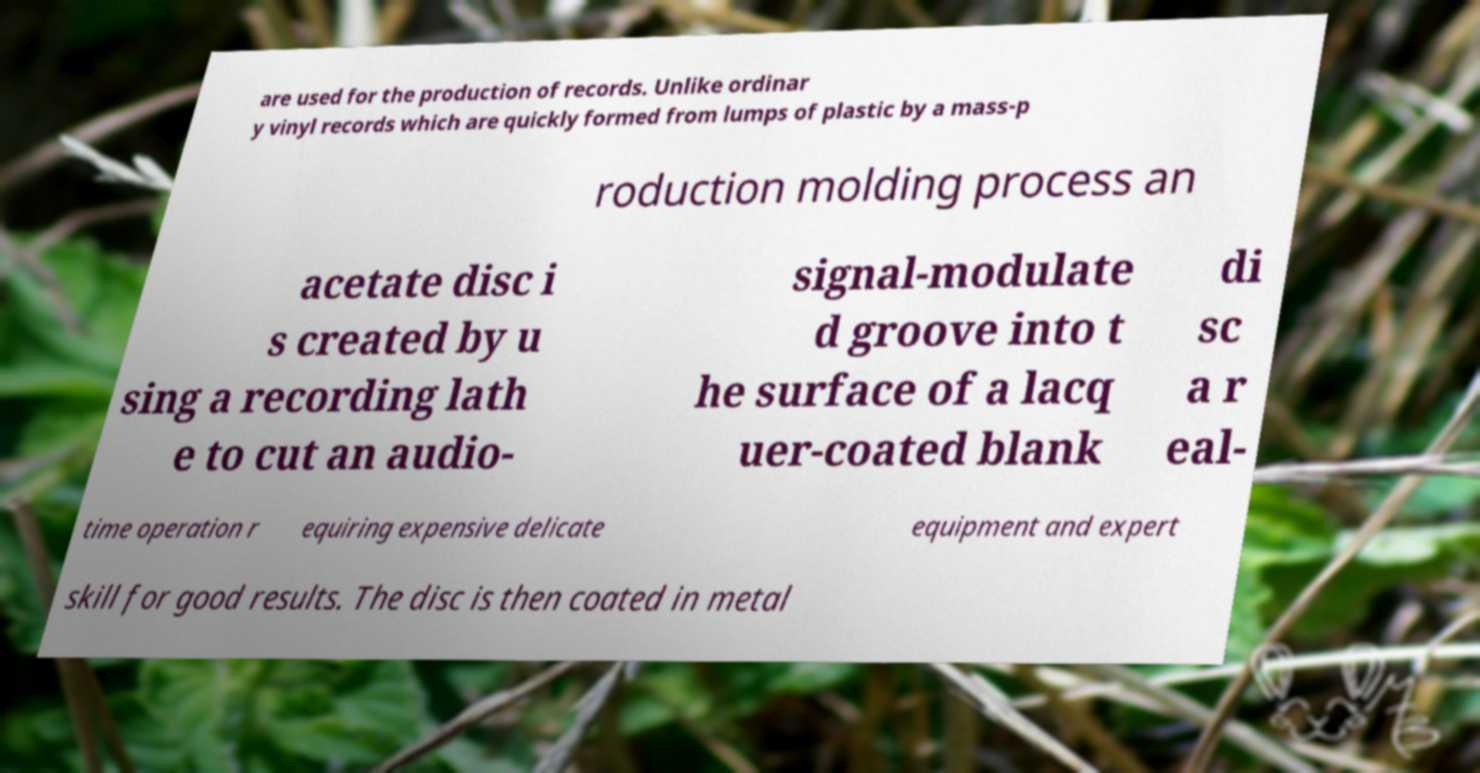Could you assist in decoding the text presented in this image and type it out clearly? are used for the production of records. Unlike ordinar y vinyl records which are quickly formed from lumps of plastic by a mass-p roduction molding process an acetate disc i s created by u sing a recording lath e to cut an audio- signal-modulate d groove into t he surface of a lacq uer-coated blank di sc a r eal- time operation r equiring expensive delicate equipment and expert skill for good results. The disc is then coated in metal 